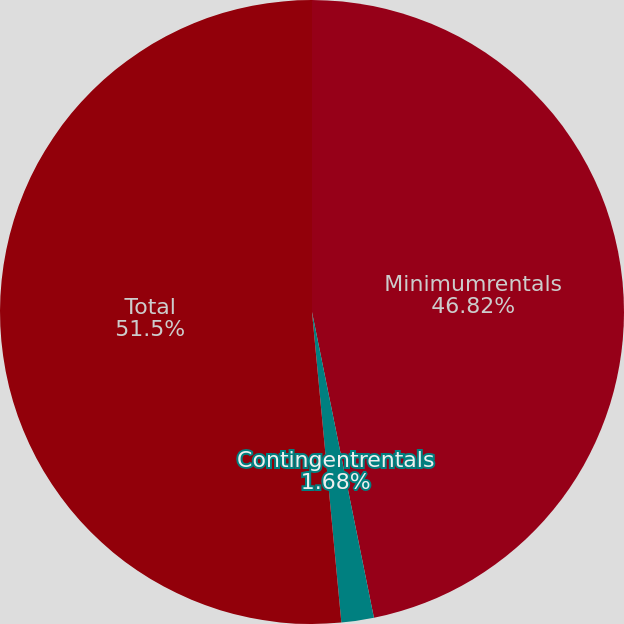Convert chart. <chart><loc_0><loc_0><loc_500><loc_500><pie_chart><fcel>Minimumrentals<fcel>Contingentrentals<fcel>Total<nl><fcel>46.82%<fcel>1.68%<fcel>51.5%<nl></chart> 